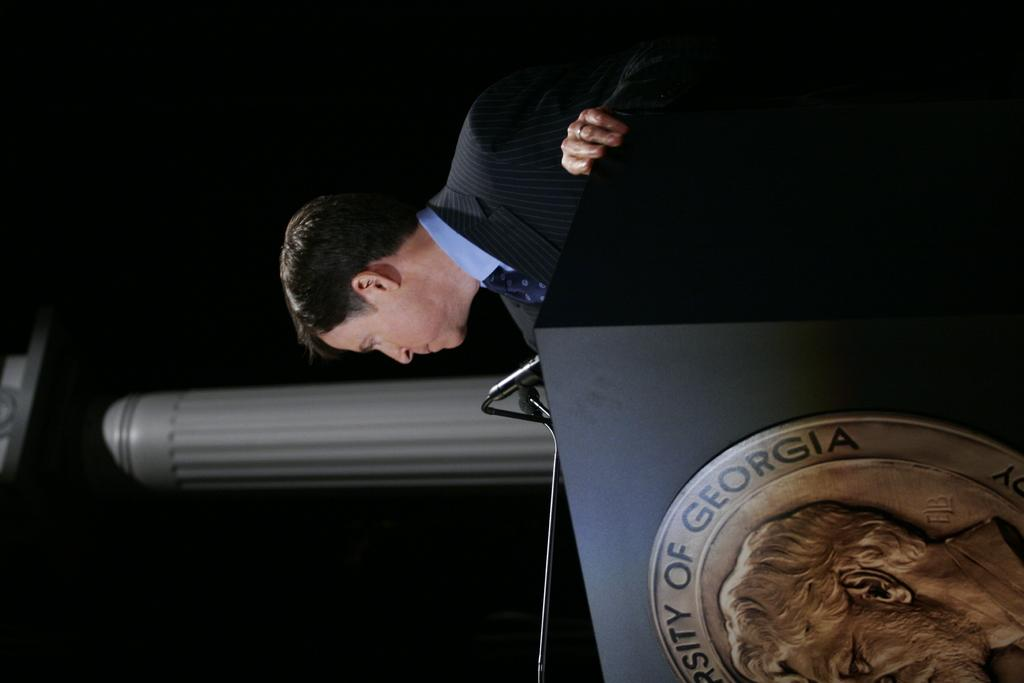Who is present in the image? There is a man in the image. What is the man doing in the image? The man is standing in the image. What objects are in front of the man? There are microphones in front of the man. What can be seen in the background of the image? There is a pillar in the background of the image. What is on the podium in the image? There is a logo on the podium in the image. What type of stick can be seen in the scene? There is no stick present in the image. How many turkeys are visible in the image? There are no turkeys present in the image. 